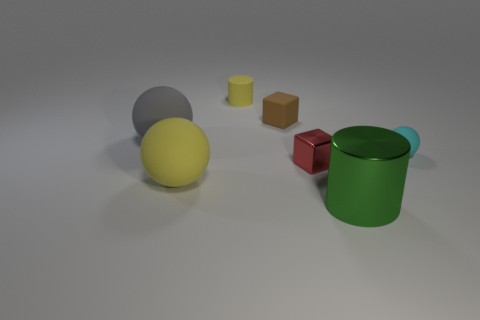What size is the yellow thing that is behind the tiny matte object on the right side of the brown cube?
Give a very brief answer. Small. What is the sphere to the right of the matte cylinder made of?
Give a very brief answer. Rubber. There is a cylinder that is made of the same material as the small sphere; what size is it?
Offer a very short reply. Small. What number of small metal objects are the same shape as the tiny brown rubber object?
Provide a short and direct response. 1. There is a tiny yellow thing; is it the same shape as the large thing that is right of the tiny yellow thing?
Offer a terse response. Yes. There is a large object that is the same color as the tiny matte cylinder; what shape is it?
Your response must be concise. Sphere. Are there any red objects that have the same material as the large green thing?
Your response must be concise. Yes. What is the cylinder that is in front of the ball that is to the right of the yellow ball made of?
Provide a short and direct response. Metal. How big is the ball on the right side of the matte sphere in front of the cube on the right side of the tiny brown matte block?
Ensure brevity in your answer.  Small. How many other objects are there of the same shape as the big green object?
Provide a short and direct response. 1. 